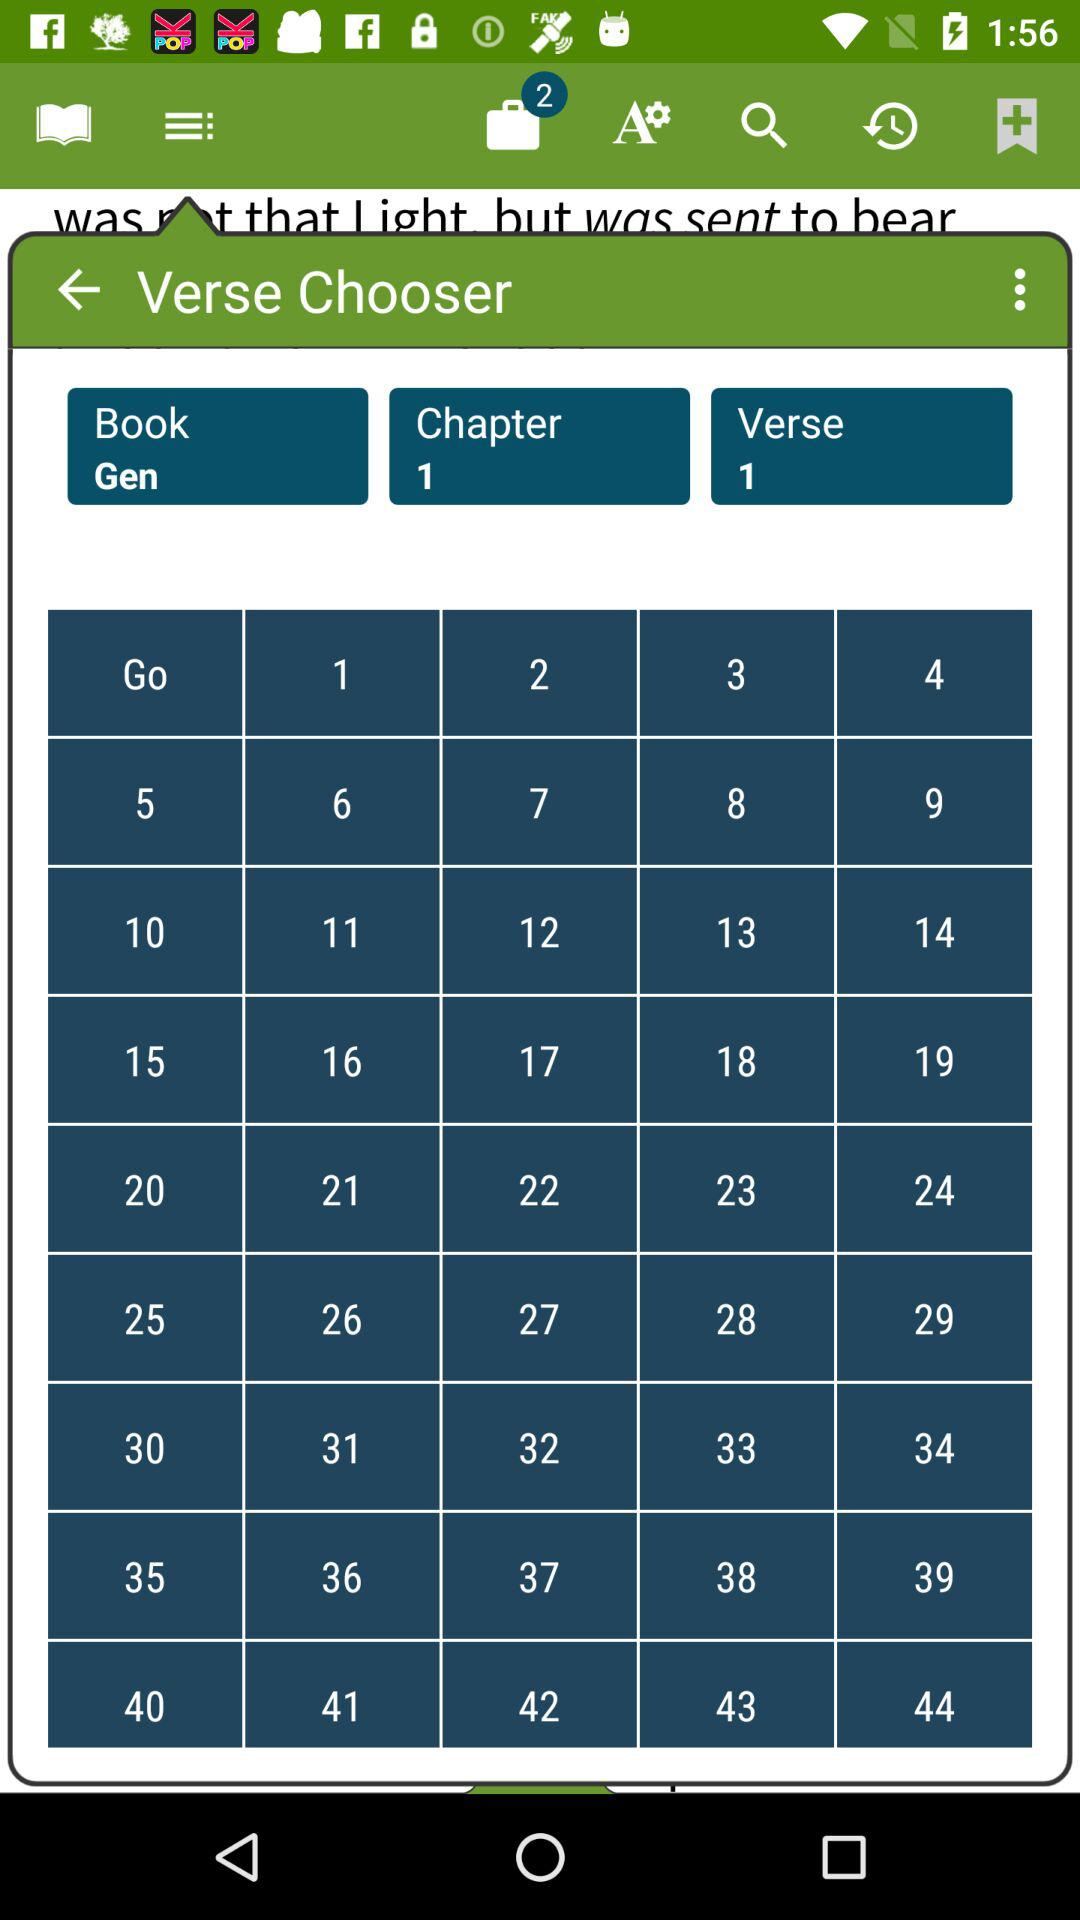Which book is selected? The selected book is "Gen". 